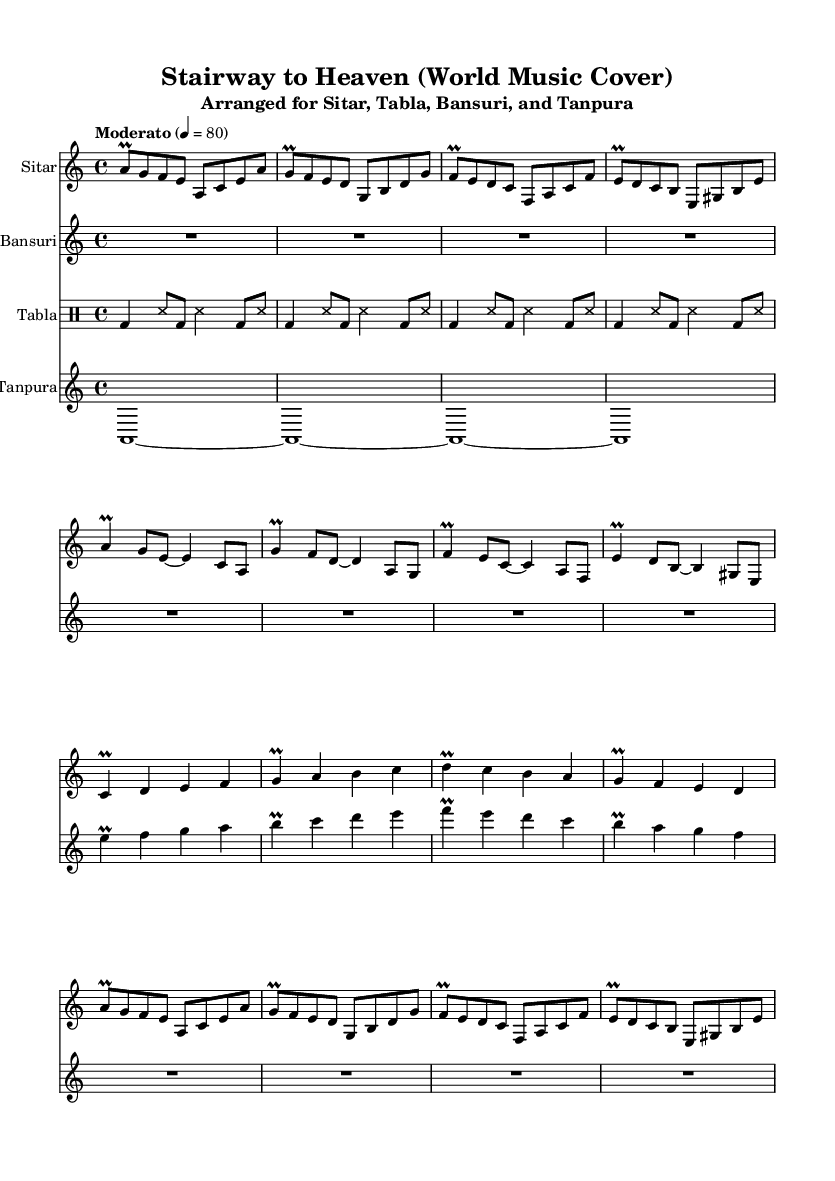What is the key signature of this music? The key signature indicates the piece is in A minor, which has no sharps or flats. This can be determined by looking at the beginning of the score where the key signature is notated.
Answer: A minor What is the time signature of the piece? The time signature is indicated at the beginning of the score, stating 4/4, which means there are four beats in a measure, and a quarter note gets one beat.
Answer: 4/4 What is the tempo marking for this arrangement? The tempo marking is found in the header section of the score, indicating that the piece is to be played in a Moderato tempo at 80 beats per minute.
Answer: Moderato, 80 Which instruments are featured in this arrangement? The instruments are specified in the header as Sitar, Tabla, Bansuri, and Tanpura. Each staff in the score is labeled accordingly, allowing for easy identification.
Answer: Sitar, Tabla, Bansuri, Tanpura How many measures does the Intro section contain? By counting the measures of music specifically notated as the Intro, we see it consists of 4 measures for the Sitar part alone, with the Bansuri also keeping its part during this section.
Answer: 4 What kind of rhythmic pattern is used for the Tabla? The rhythmic pattern is based on a simplified Teental pattern, which can be identified by the sequences of beat types (bd for bass drum, ss for stroke) throughout the piece.
Answer: Teental What is the primary function of the Tanpura in this arrangement? The Tanpura serves to provide a continuous drone throughout the piece, which is noted by the sustained A notes that appear throughout the score.
Answer: Continuous drone 